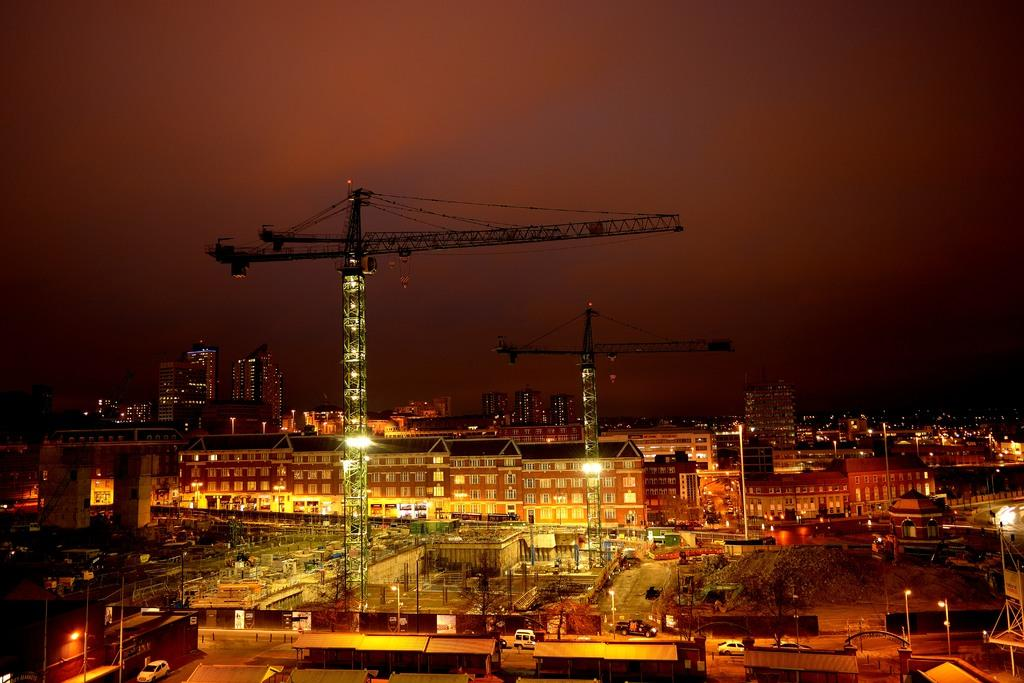What types of structures are visible in the image? There are buildings, houses, poles, and towers in the image. What features can be seen on the structures? There are lights, trees, walls, and windows visible on the structures. What is visible in the background of the image? The sky is visible in the background of the image. How many eyes can be seen on the grape in the image? There is no grape present in the image, and therefore no eyes can be seen on it. 